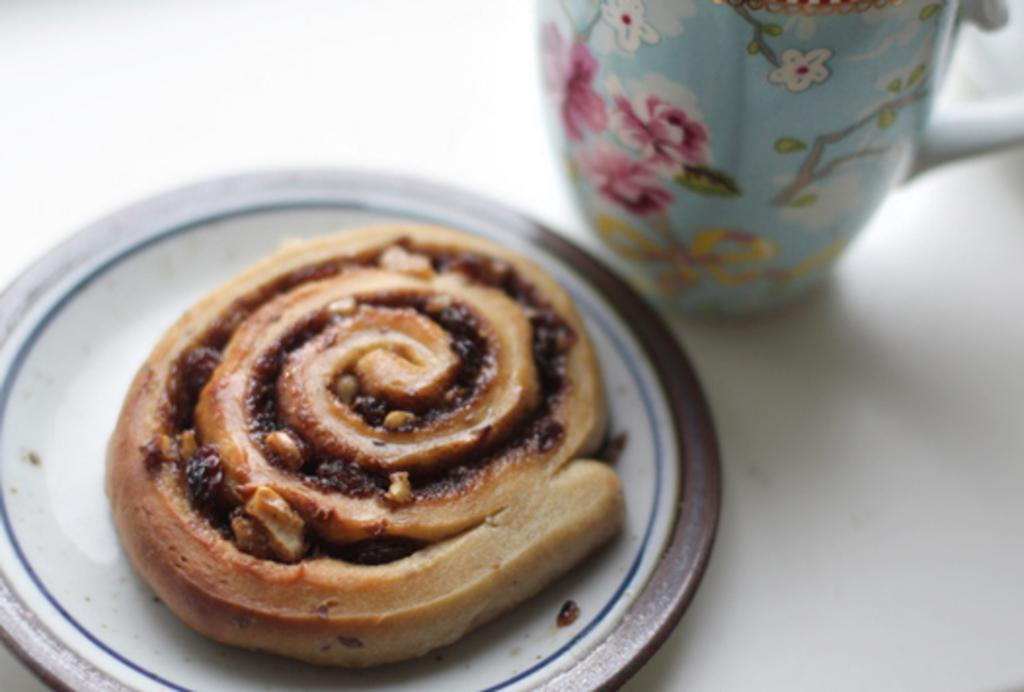What is present on the plate in the image? The plate contains a food item. What is placed beside the plate in the image? There is a cup placed beside the plate. Can you describe the food item on the plate? Unfortunately, the specific food item cannot be determined from the provided facts. How many legs can be seen on the plate in the image? Plates do not have legs, so there are none visible in the image. 